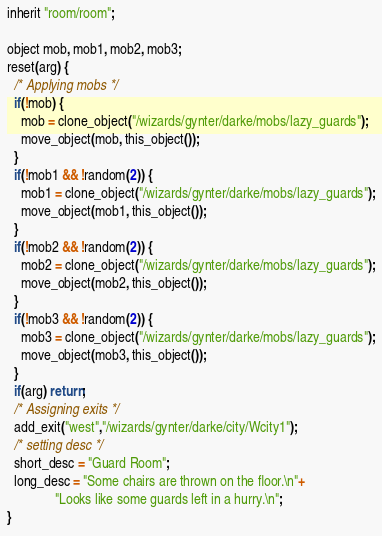Convert code to text. <code><loc_0><loc_0><loc_500><loc_500><_C_>inherit "room/room";

object mob, mob1, mob2, mob3;
reset(arg) {
  /* Applying mobs */
  if(!mob) {
    mob = clone_object("/wizards/gynter/darke/mobs/lazy_guards");
    move_object(mob, this_object());
  }
  if(!mob1 && !random(2)) {
    mob1 = clone_object("/wizards/gynter/darke/mobs/lazy_guards");
    move_object(mob1, this_object());
  }
  if(!mob2 && !random(2)) {
    mob2 = clone_object("/wizards/gynter/darke/mobs/lazy_guards");
    move_object(mob2, this_object());
  }
  if(!mob3 && !random(2)) {
    mob3 = clone_object("/wizards/gynter/darke/mobs/lazy_guards");
    move_object(mob3, this_object());
  }
  if(arg) return;
  /* Assigning exits */
  add_exit("west","/wizards/gynter/darke/city/Wcity1");
  /* setting desc */
  short_desc = "Guard Room";
  long_desc = "Some chairs are thrown on the floor.\n"+
              "Looks like some guards left in a hurry.\n";
}
</code> 